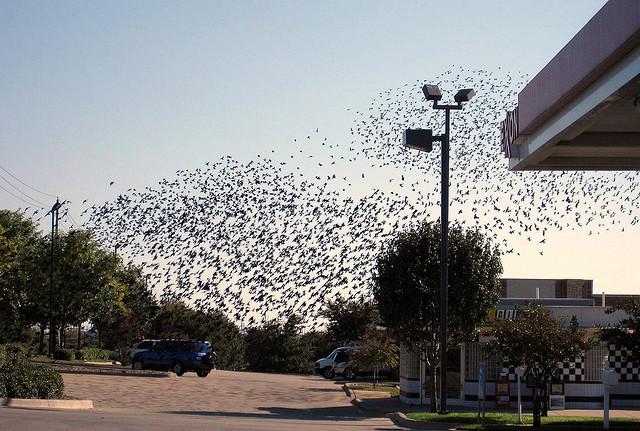What brand of gas station is shown in the picture?
Answer briefly. Exxon. What are all those things in the sky?
Keep it brief. Birds. How many newspaper vending machines are there?
Write a very short answer. 2. 